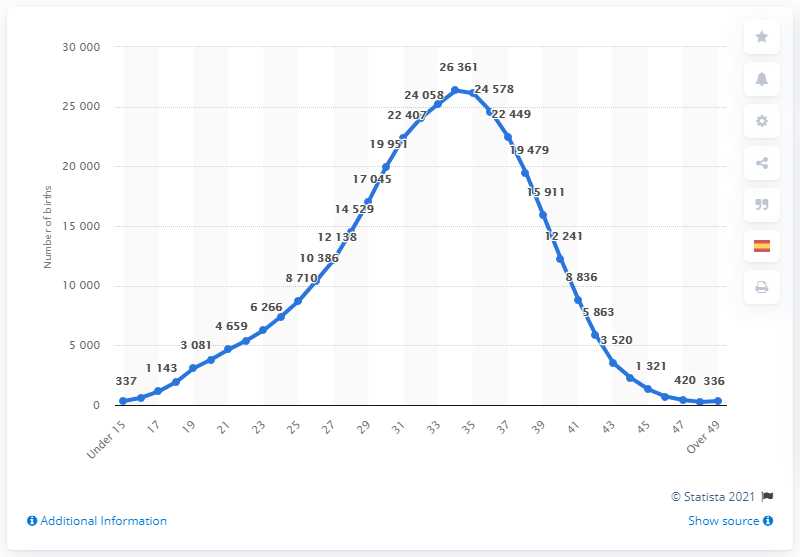Give some essential details in this illustration. There were 26,124 births between the ages of 34 and 35 in Spain in 2019. 